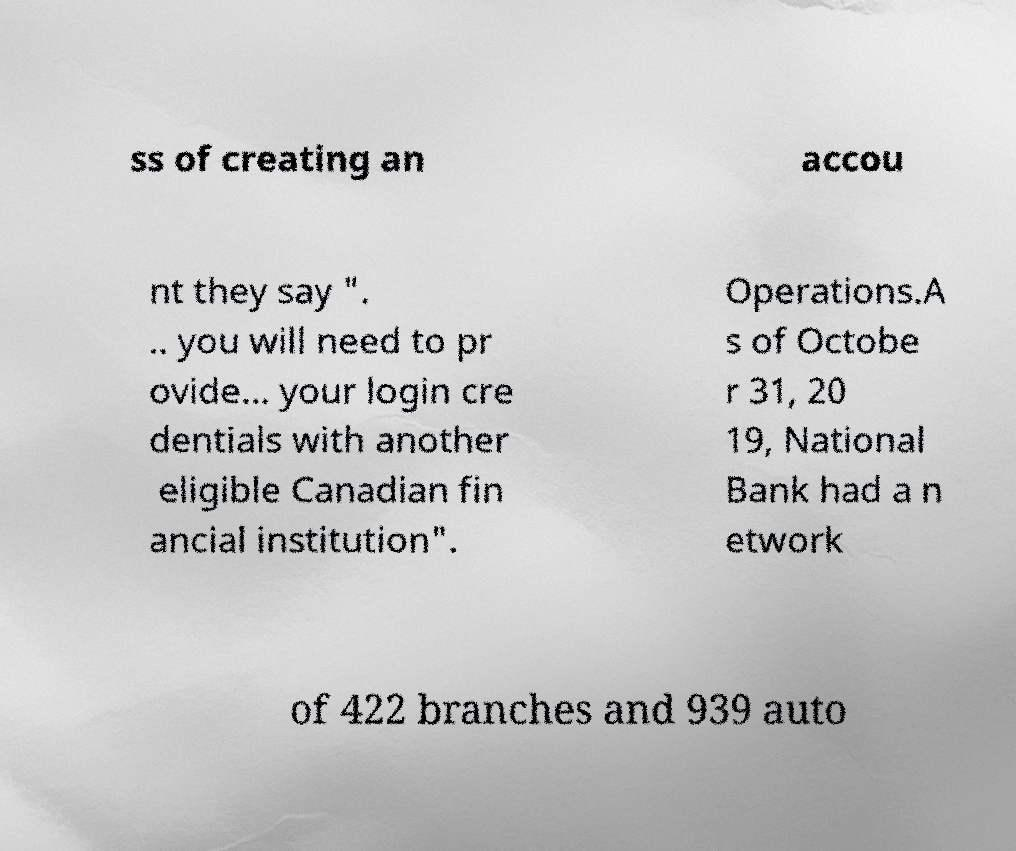Can you accurately transcribe the text from the provided image for me? ss of creating an accou nt they say ". .. you will need to pr ovide... your login cre dentials with another eligible Canadian fin ancial institution". Operations.A s of Octobe r 31, 20 19, National Bank had a n etwork of 422 branches and 939 auto 